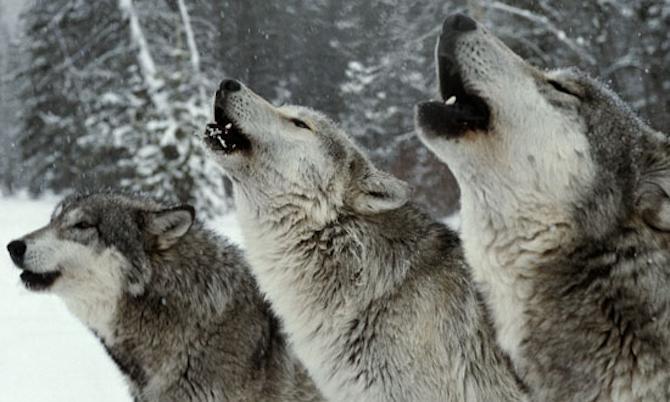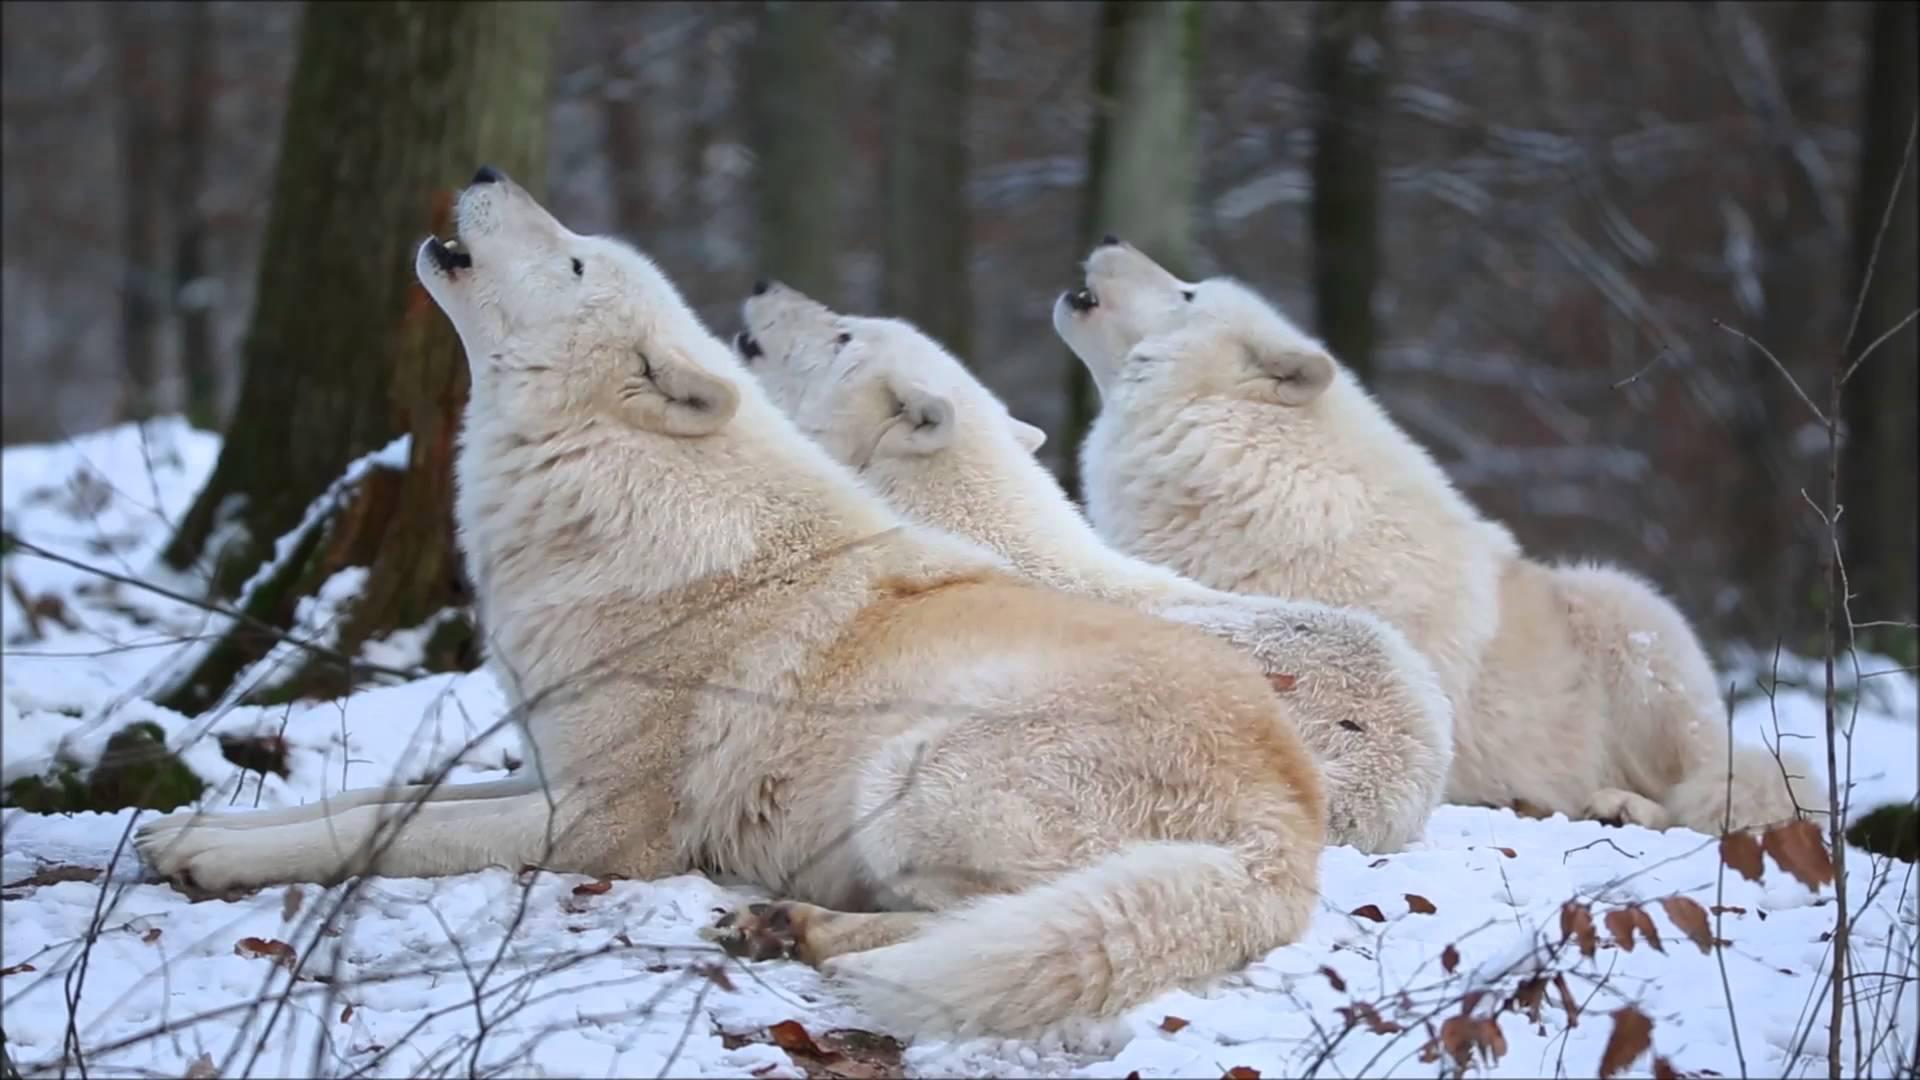The first image is the image on the left, the second image is the image on the right. Given the left and right images, does the statement "The right image contains five wolves." hold true? Answer yes or no. No. The first image is the image on the left, the second image is the image on the right. Analyze the images presented: Is the assertion "One image contains only non-howling wolves with non-raised heads, and the other image includes wolves howling with raised heads." valid? Answer yes or no. No. 